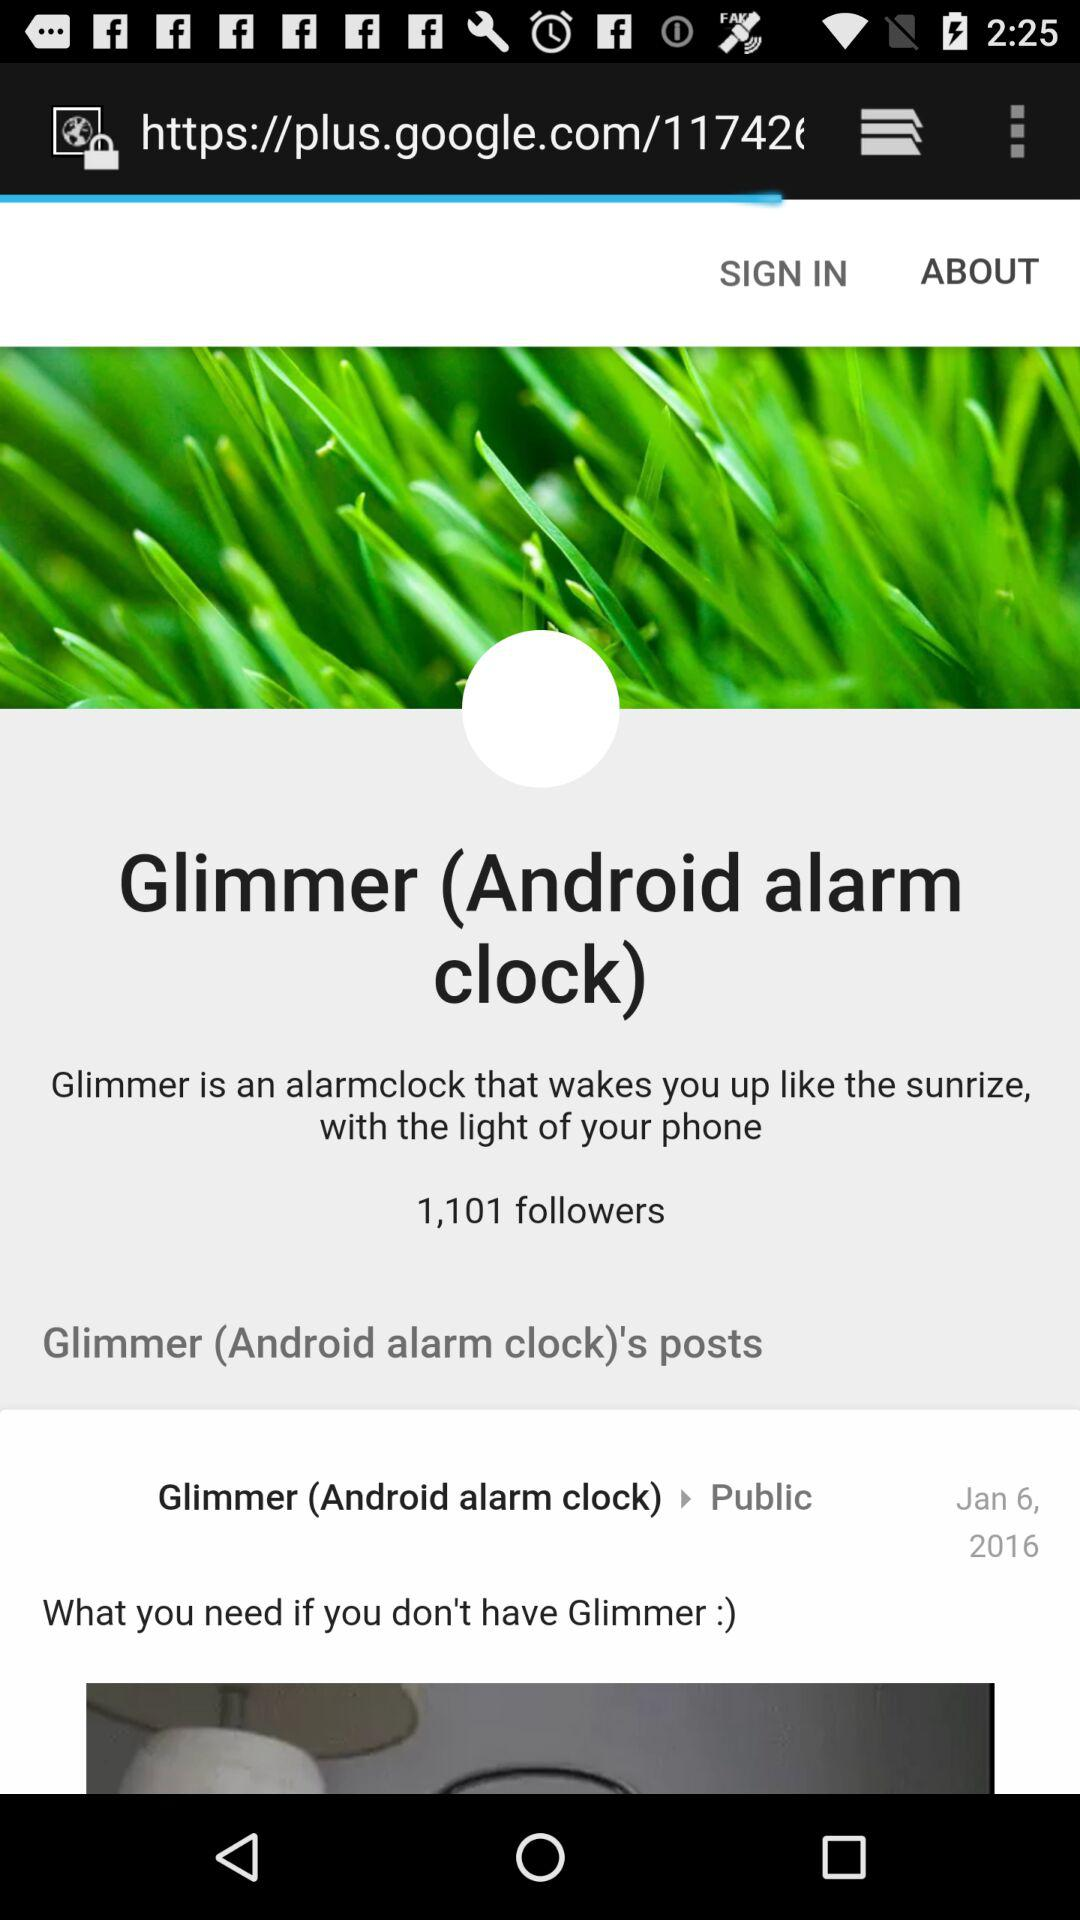What is the date for "Glimmer"? The date is January 6, 2016. 